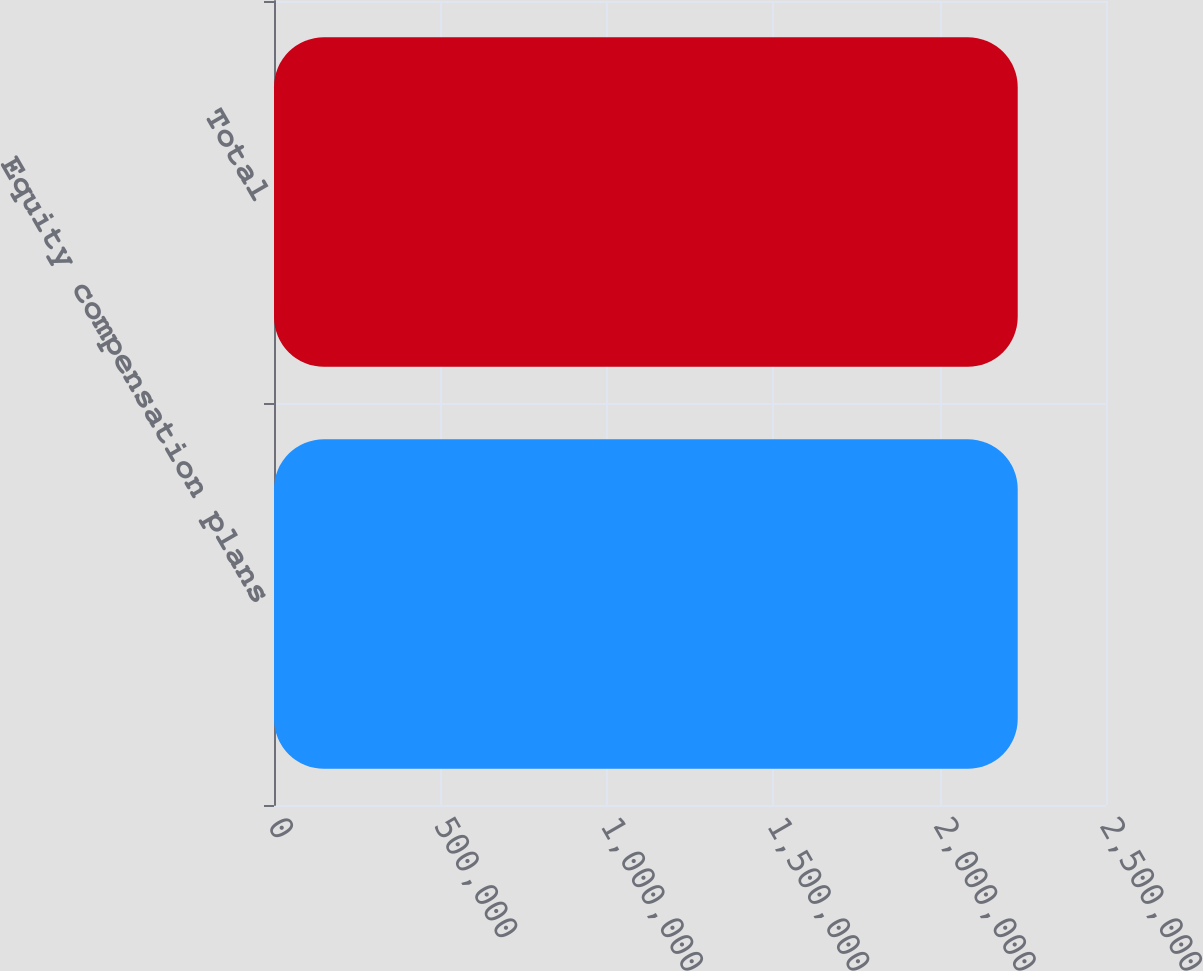Convert chart to OTSL. <chart><loc_0><loc_0><loc_500><loc_500><bar_chart><fcel>Equity compensation plans<fcel>Total<nl><fcel>2.23472e+06<fcel>2.23472e+06<nl></chart> 